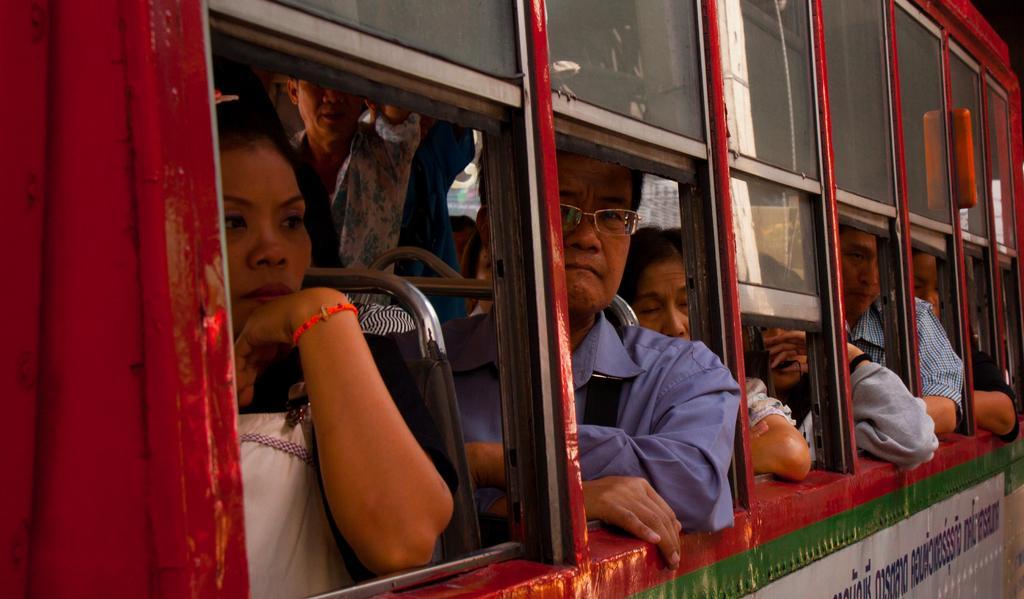Could you give a brief overview of what you see in this image? In this image we can see a few people sitting and standing in a vehicle. 